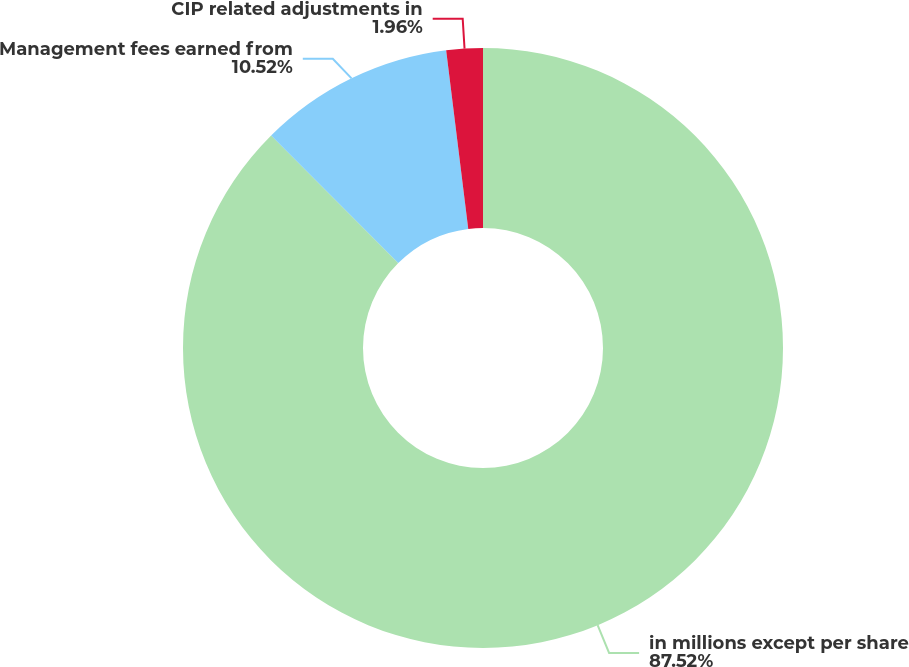Convert chart to OTSL. <chart><loc_0><loc_0><loc_500><loc_500><pie_chart><fcel>in millions except per share<fcel>Management fees earned from<fcel>CIP related adjustments in<nl><fcel>87.52%<fcel>10.52%<fcel>1.96%<nl></chart> 